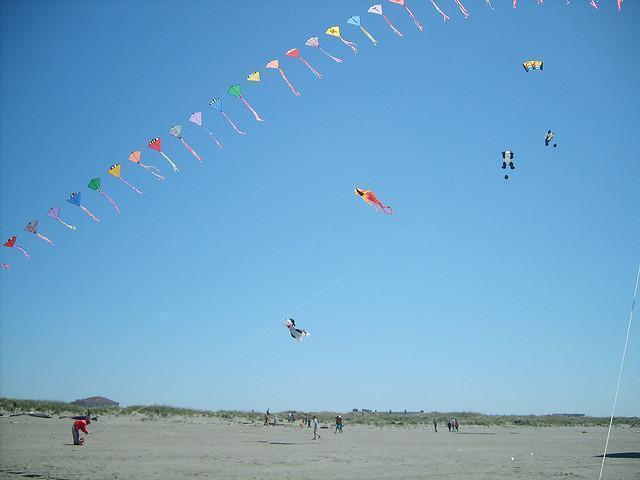How many kites resemble fish?
Give a very brief answer. 1. How many kites are visible?
Give a very brief answer. 1. How many circle donuts are there?
Give a very brief answer. 0. 